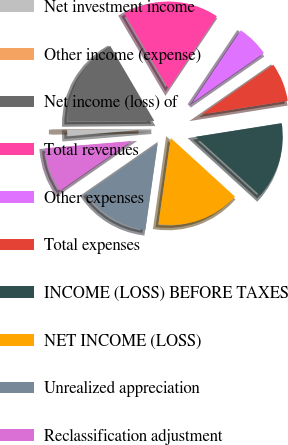Convert chart to OTSL. <chart><loc_0><loc_0><loc_500><loc_500><pie_chart><fcel>Net investment income<fcel>Other income (expense)<fcel>Net income (loss) of<fcel>Total revenues<fcel>Other expenses<fcel>Total expenses<fcel>INCOME (LOSS) BEFORE TAXES<fcel>NET INCOME (LOSS)<fcel>Unrealized appreciation<fcel>Reclassification adjustment<nl><fcel>1.2%<fcel>0.01%<fcel>16.66%<fcel>17.85%<fcel>5.96%<fcel>7.15%<fcel>14.28%<fcel>15.47%<fcel>13.09%<fcel>8.33%<nl></chart> 